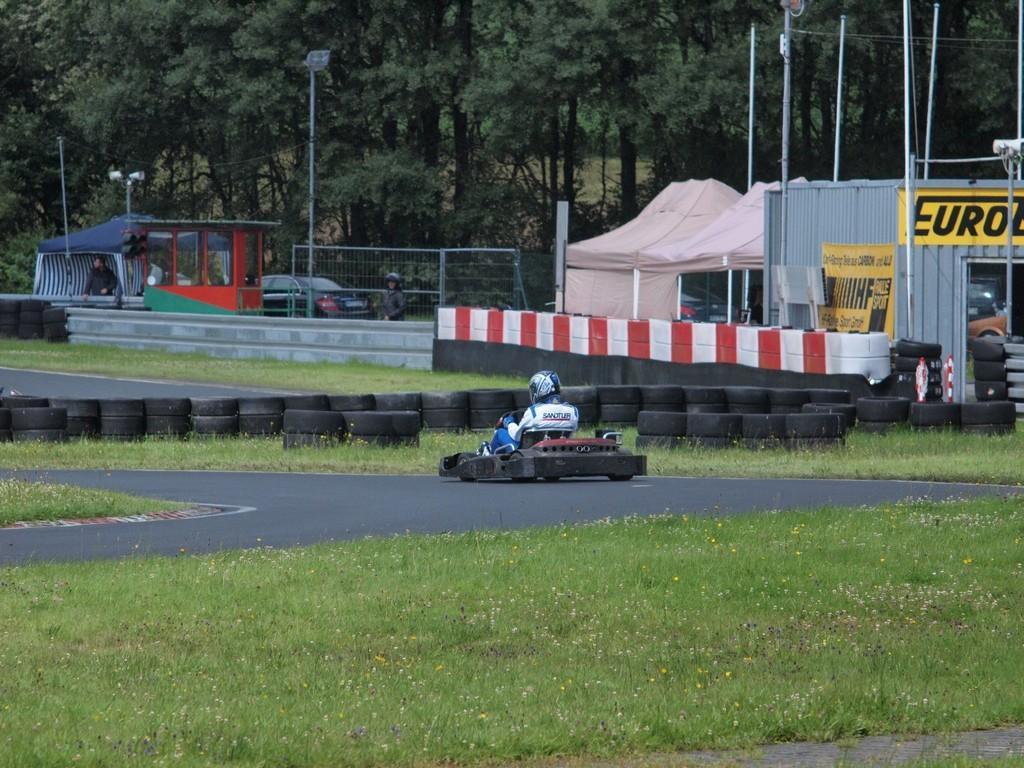Describe this image in one or two sentences. In this picture, there is a road in the center. On the road, there is a vehicle and a person sitting in it. At the bottom, there is grass. In the center, there are tiers, tents, shed etc. In the background, there are people, fence, pole, trees etc. 